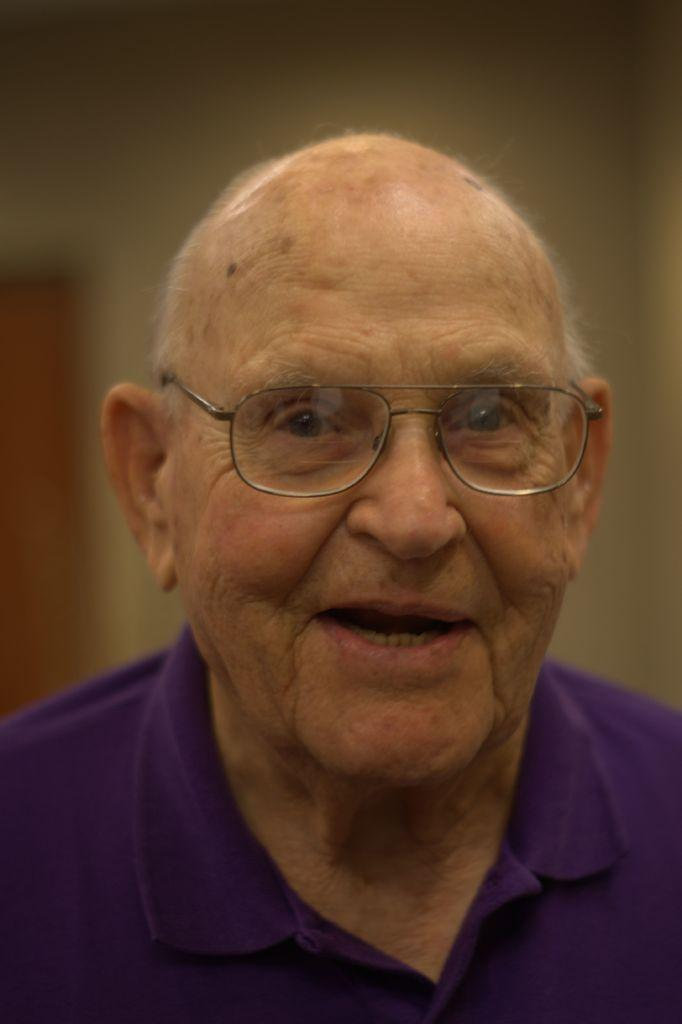Who is present in the image? There is a man in the image. What accessory is the man wearing? The man is wearing spectacles. Can you describe the background of the image? The background of the image is blurred. What type of pancake is the man flipping in the image? There is no pancake present in the image, and the man is not flipping anything. 